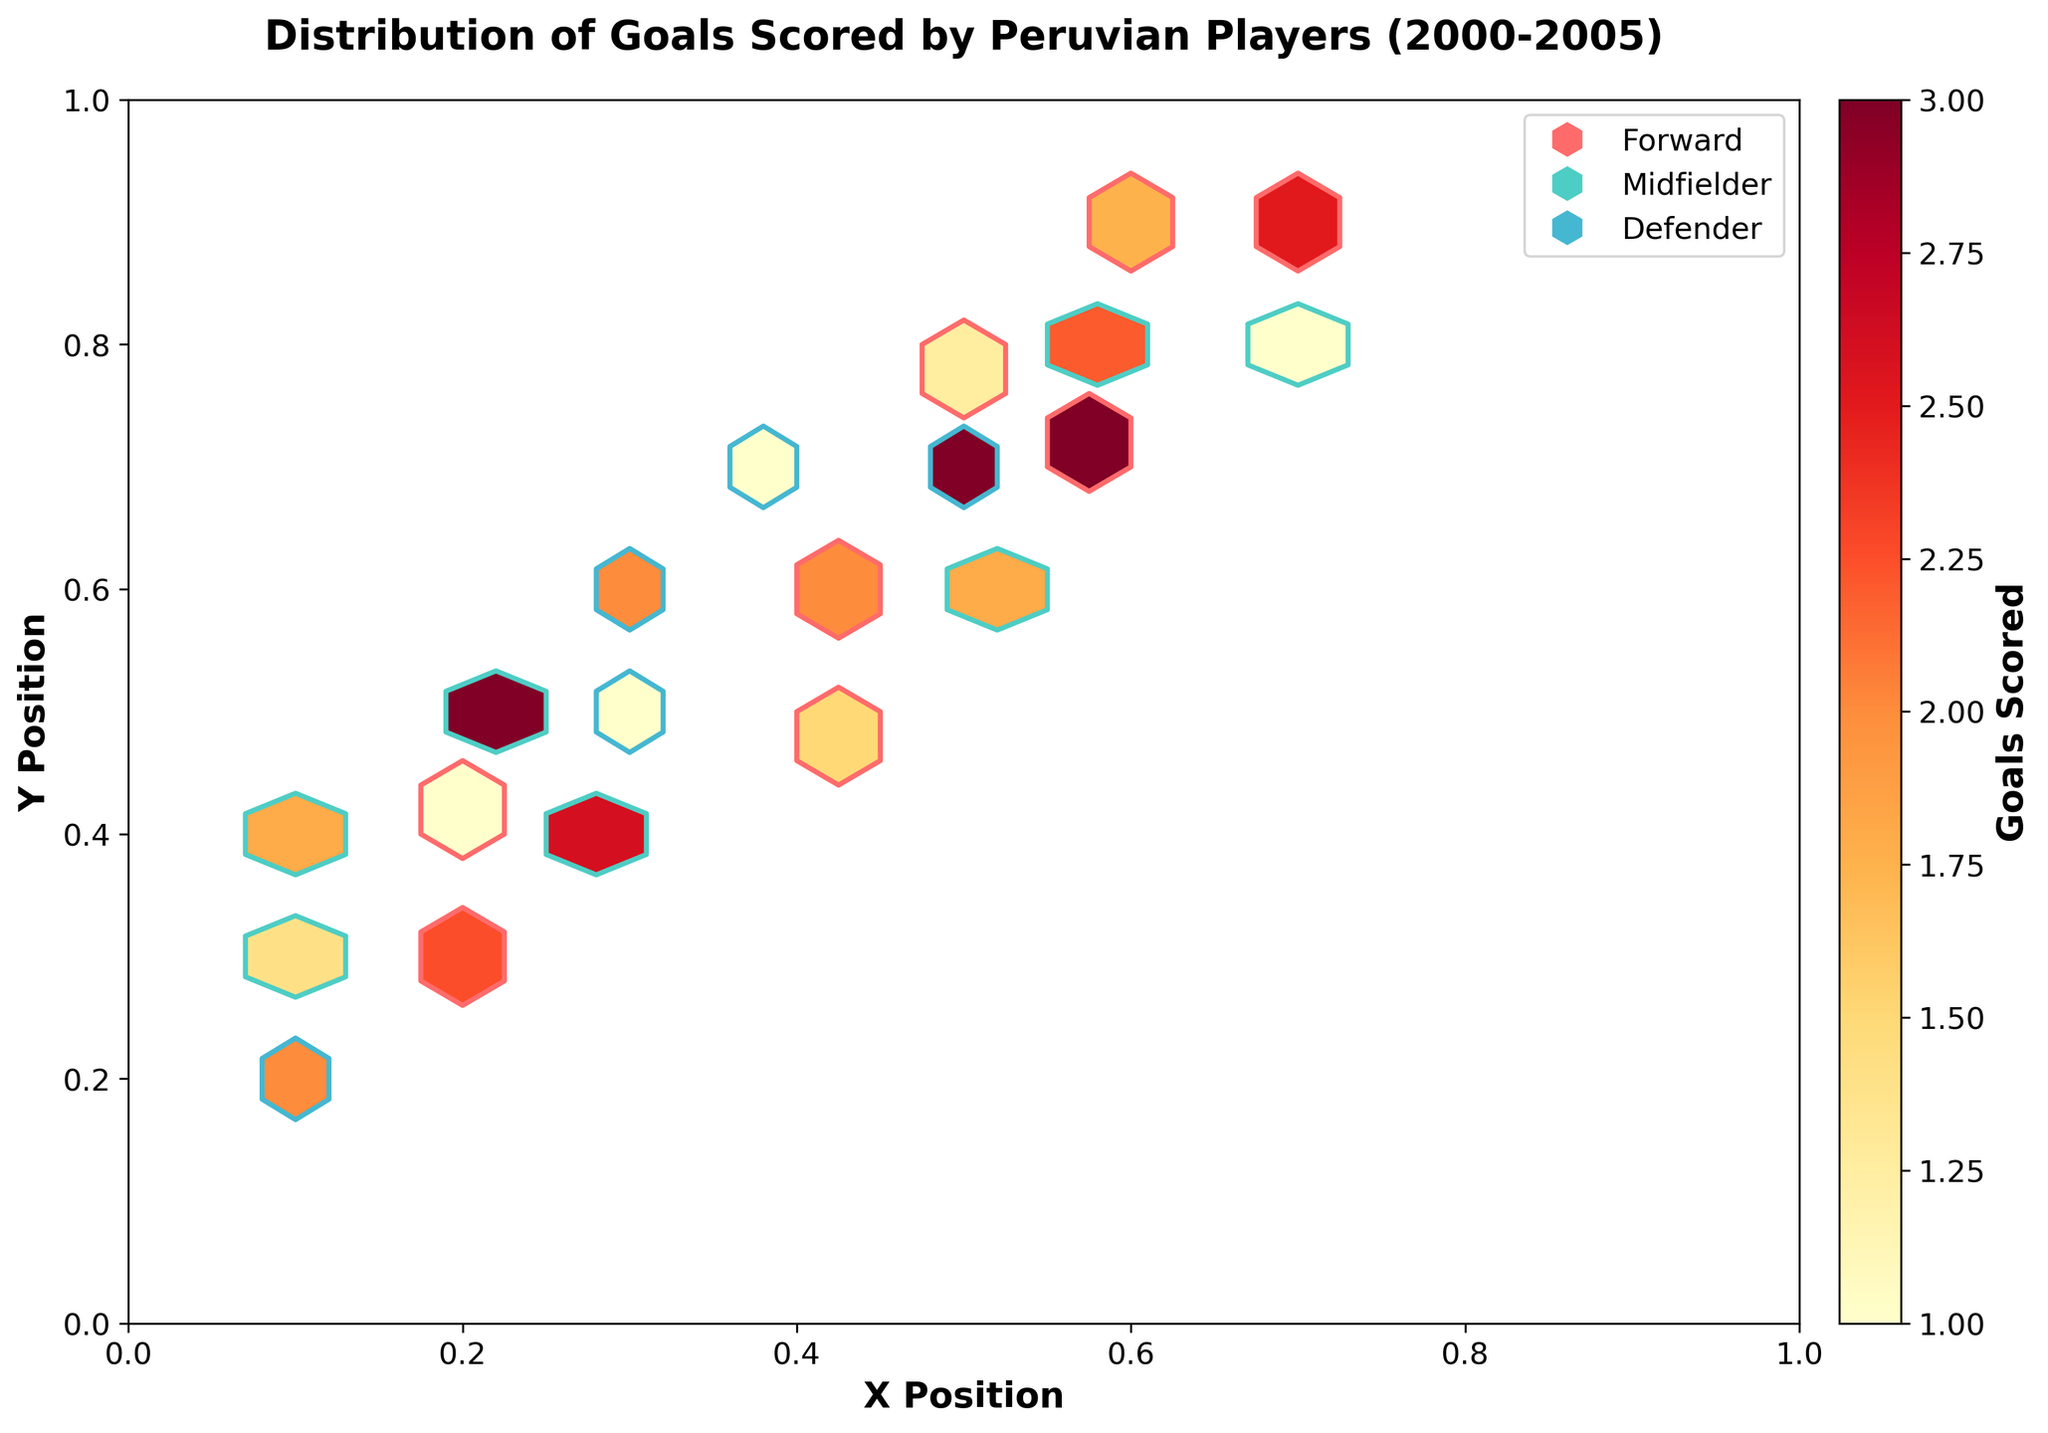What is the title of the plot? The title of the plot is usually located at the top of the figure. The plot title here is "Distribution of Goals Scored by Peruvian Players (2000-2005)."
Answer: Distribution of Goals Scored by Peruvian Players (2000-2005) How many different player positions are shown in the plot? The legend in the plot indicates the different player positions by using different colors and markers. You can see three different elements corresponding to "Forward," "Midfielder," and "Defender."
Answer: 3 Which player position is represented by the red hexagons? The plot legend uses different colors to represent player positions. Based on the legend, the red hexagons represent the "Forward" position.
Answer: Forward What range of goals scored is represented in the color bar? The color bar usually shows the range of values it represents. By looking at the color bar in the figure, it indicates the goals scored range from 1 to 18.
Answer: 1 to 18 Which player position achieved the highest number of goals, and what is that value? By observing the color coding in the hexbin plot and referencing the color bar, the Forward position has the darkest red hexagon indicating the highest number of goals. The color bar shows this corresponds to a value of 18 goals.
Answer: Forward, 18 Which area (x, y coordinates) has the highest density of goals scored? Areas with the darkest colors on the hexbin plot indicate the highest density. The deep red hexagons around coordinates (0.6, 0.7) show the highest density of goals scored.
Answer: (0.6, 0.7) How does the density of goals scored by Midfielders compare to Forwards in terms of concentration? The hexbin plot uses color intensity to show density. By comparing the hexagons for Midfielders (green) and Forwards (red), the red hexagons are generally darker, indicating a higher concentration for Forwards.
Answer: Forwards have a higher concentration What is the median number of goals scored by Midfielders based on visible hexagons? To determine the median, list the goals in ascending order: 4, 5, 6, 6, 7, 8, 9. The middle value (median) in this list is 6.
Answer: 6 Which player position has the least density of goals scored in the area (0.1, 0.3)? By examining the hexbin density at coordinates (0.1, 0.3), you can see fewer colored hexagons (lighter colors) for Defenders and Midfielders compared to Forwards.
Answer: Defenders Is there a specific pattern observed in the distribution of goals scored by Defenders? Defenders tend to score fewer goals, which is reflected in generally lighter colored hexagons and more hexagons in the lower color spectrum (yellow).
Answer: Fewer goals in lower color spectrum 